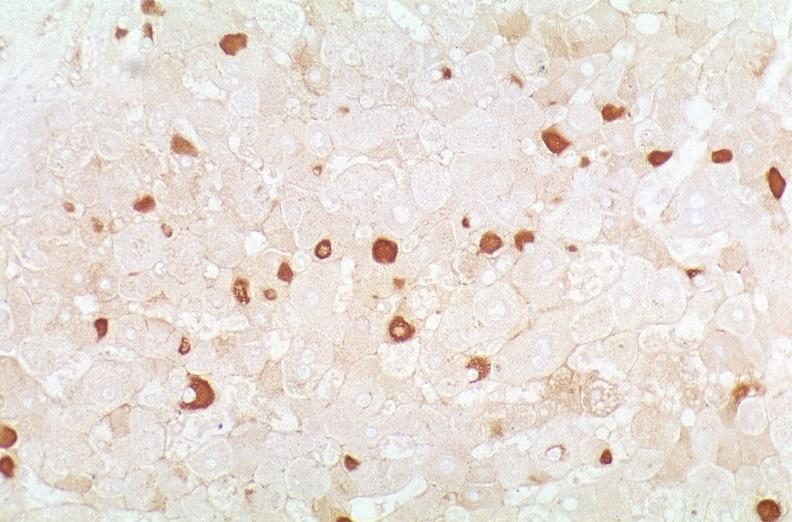what does this image show?
Answer the question using a single word or phrase. Hepatitis b virus 